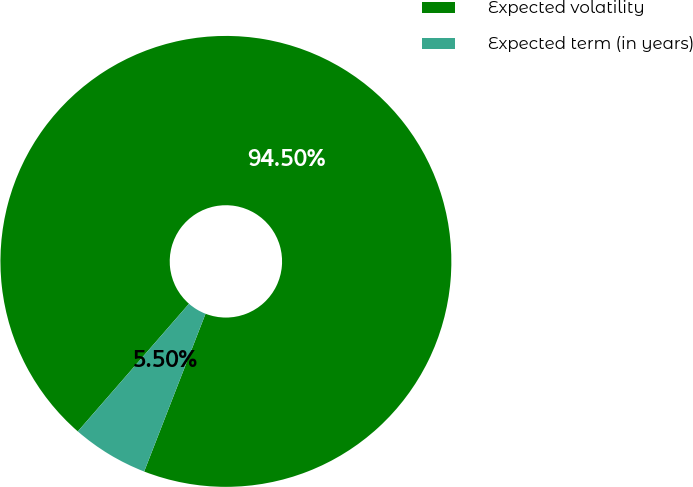Convert chart to OTSL. <chart><loc_0><loc_0><loc_500><loc_500><pie_chart><fcel>Expected volatility<fcel>Expected term (in years)<nl><fcel>94.5%<fcel>5.5%<nl></chart> 